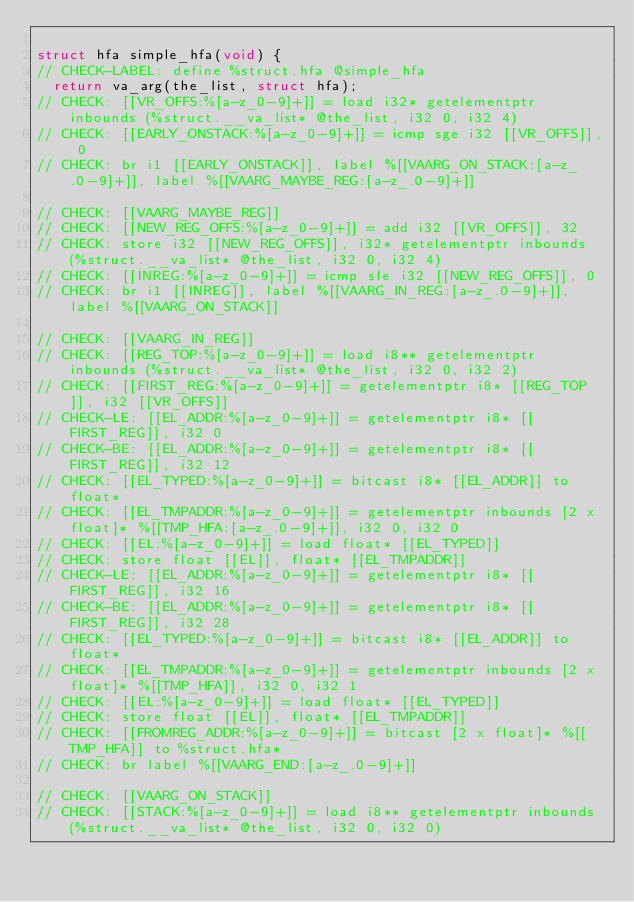<code> <loc_0><loc_0><loc_500><loc_500><_C_>
struct hfa simple_hfa(void) {
// CHECK-LABEL: define %struct.hfa @simple_hfa
  return va_arg(the_list, struct hfa);
// CHECK: [[VR_OFFS:%[a-z_0-9]+]] = load i32* getelementptr inbounds (%struct.__va_list* @the_list, i32 0, i32 4)
// CHECK: [[EARLY_ONSTACK:%[a-z_0-9]+]] = icmp sge i32 [[VR_OFFS]], 0
// CHECK: br i1 [[EARLY_ONSTACK]], label %[[VAARG_ON_STACK:[a-z_.0-9]+]], label %[[VAARG_MAYBE_REG:[a-z_.0-9]+]]

// CHECK: [[VAARG_MAYBE_REG]]
// CHECK: [[NEW_REG_OFFS:%[a-z_0-9]+]] = add i32 [[VR_OFFS]], 32
// CHECK: store i32 [[NEW_REG_OFFS]], i32* getelementptr inbounds (%struct.__va_list* @the_list, i32 0, i32 4)
// CHECK: [[INREG:%[a-z_0-9]+]] = icmp sle i32 [[NEW_REG_OFFS]], 0
// CHECK: br i1 [[INREG]], label %[[VAARG_IN_REG:[a-z_.0-9]+]], label %[[VAARG_ON_STACK]]

// CHECK: [[VAARG_IN_REG]]
// CHECK: [[REG_TOP:%[a-z_0-9]+]] = load i8** getelementptr inbounds (%struct.__va_list* @the_list, i32 0, i32 2)
// CHECK: [[FIRST_REG:%[a-z_0-9]+]] = getelementptr i8* [[REG_TOP]], i32 [[VR_OFFS]]
// CHECK-LE: [[EL_ADDR:%[a-z_0-9]+]] = getelementptr i8* [[FIRST_REG]], i32 0
// CHECK-BE: [[EL_ADDR:%[a-z_0-9]+]] = getelementptr i8* [[FIRST_REG]], i32 12
// CHECK: [[EL_TYPED:%[a-z_0-9]+]] = bitcast i8* [[EL_ADDR]] to float*
// CHECK: [[EL_TMPADDR:%[a-z_0-9]+]] = getelementptr inbounds [2 x float]* %[[TMP_HFA:[a-z_.0-9]+]], i32 0, i32 0
// CHECK: [[EL:%[a-z_0-9]+]] = load float* [[EL_TYPED]]
// CHECK: store float [[EL]], float* [[EL_TMPADDR]]
// CHECK-LE: [[EL_ADDR:%[a-z_0-9]+]] = getelementptr i8* [[FIRST_REG]], i32 16
// CHECK-BE: [[EL_ADDR:%[a-z_0-9]+]] = getelementptr i8* [[FIRST_REG]], i32 28
// CHECK: [[EL_TYPED:%[a-z_0-9]+]] = bitcast i8* [[EL_ADDR]] to float*
// CHECK: [[EL_TMPADDR:%[a-z_0-9]+]] = getelementptr inbounds [2 x float]* %[[TMP_HFA]], i32 0, i32 1
// CHECK: [[EL:%[a-z_0-9]+]] = load float* [[EL_TYPED]]
// CHECK: store float [[EL]], float* [[EL_TMPADDR]]
// CHECK: [[FROMREG_ADDR:%[a-z_0-9]+]] = bitcast [2 x float]* %[[TMP_HFA]] to %struct.hfa*
// CHECK: br label %[[VAARG_END:[a-z_.0-9]+]]

// CHECK: [[VAARG_ON_STACK]]
// CHECK: [[STACK:%[a-z_0-9]+]] = load i8** getelementptr inbounds (%struct.__va_list* @the_list, i32 0, i32 0)</code> 